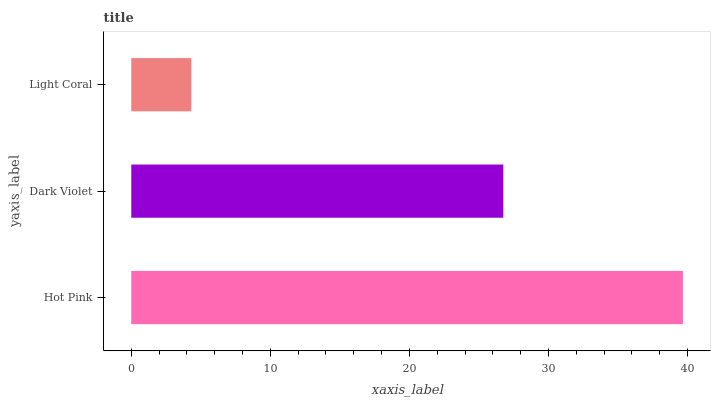Is Light Coral the minimum?
Answer yes or no. Yes. Is Hot Pink the maximum?
Answer yes or no. Yes. Is Dark Violet the minimum?
Answer yes or no. No. Is Dark Violet the maximum?
Answer yes or no. No. Is Hot Pink greater than Dark Violet?
Answer yes or no. Yes. Is Dark Violet less than Hot Pink?
Answer yes or no. Yes. Is Dark Violet greater than Hot Pink?
Answer yes or no. No. Is Hot Pink less than Dark Violet?
Answer yes or no. No. Is Dark Violet the high median?
Answer yes or no. Yes. Is Dark Violet the low median?
Answer yes or no. Yes. Is Light Coral the high median?
Answer yes or no. No. Is Hot Pink the low median?
Answer yes or no. No. 